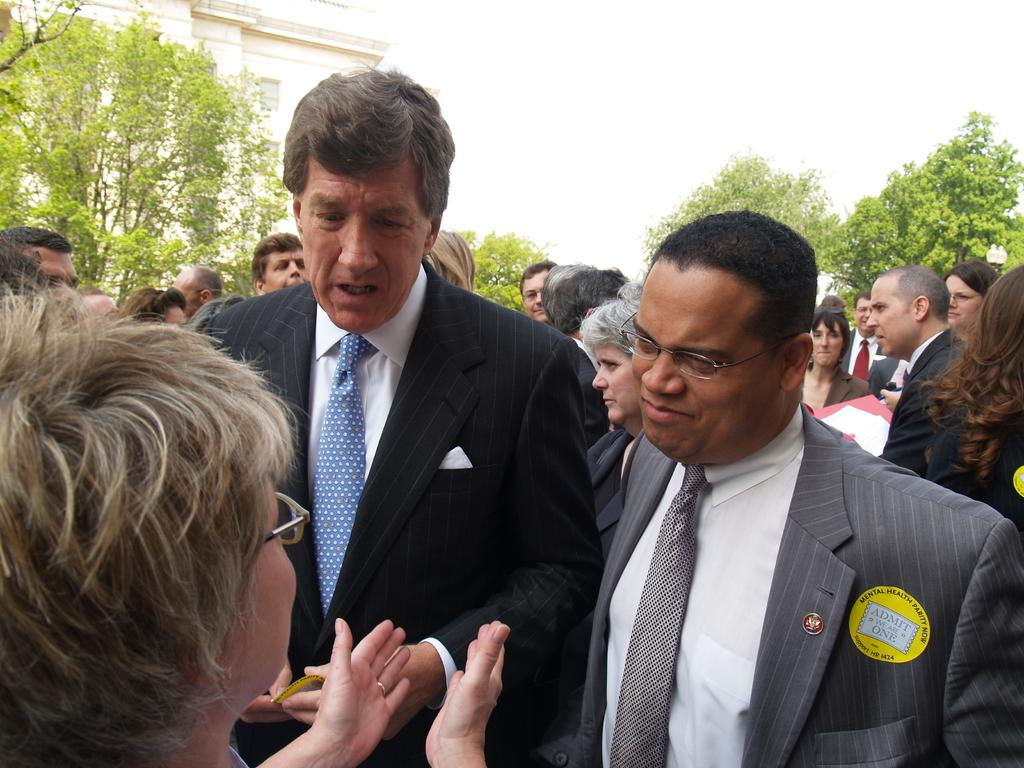What can be seen in the image? There are people standing in the image, along with trees, a building, and the sky. Where are the trees located in the image? The trees are in the middle of the image. What is on the left side of the image? There is a building on the left side of the image. What is visible at the top of the image? The sky is visible at the top of the image. What type of toy can be seen being forced by the people in the image? There is no toy present in the image, nor is any force being applied by the people. 